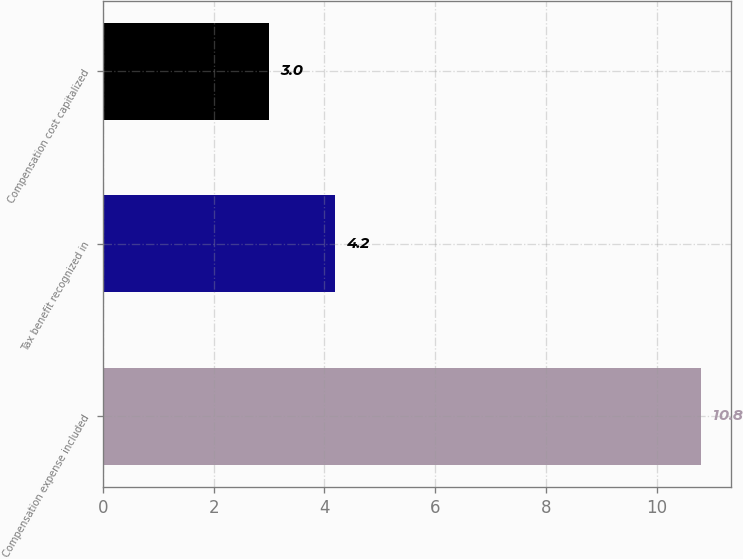<chart> <loc_0><loc_0><loc_500><loc_500><bar_chart><fcel>Compensation expense included<fcel>Tax benefit recognized in<fcel>Compensation cost capitalized<nl><fcel>10.8<fcel>4.2<fcel>3<nl></chart> 